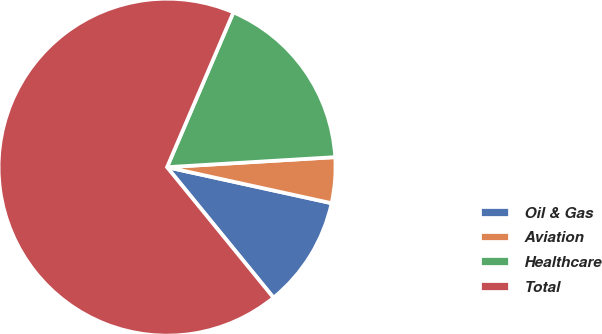Convert chart to OTSL. <chart><loc_0><loc_0><loc_500><loc_500><pie_chart><fcel>Oil & Gas<fcel>Aviation<fcel>Healthcare<fcel>Total<nl><fcel>10.68%<fcel>4.38%<fcel>17.61%<fcel>67.33%<nl></chart> 